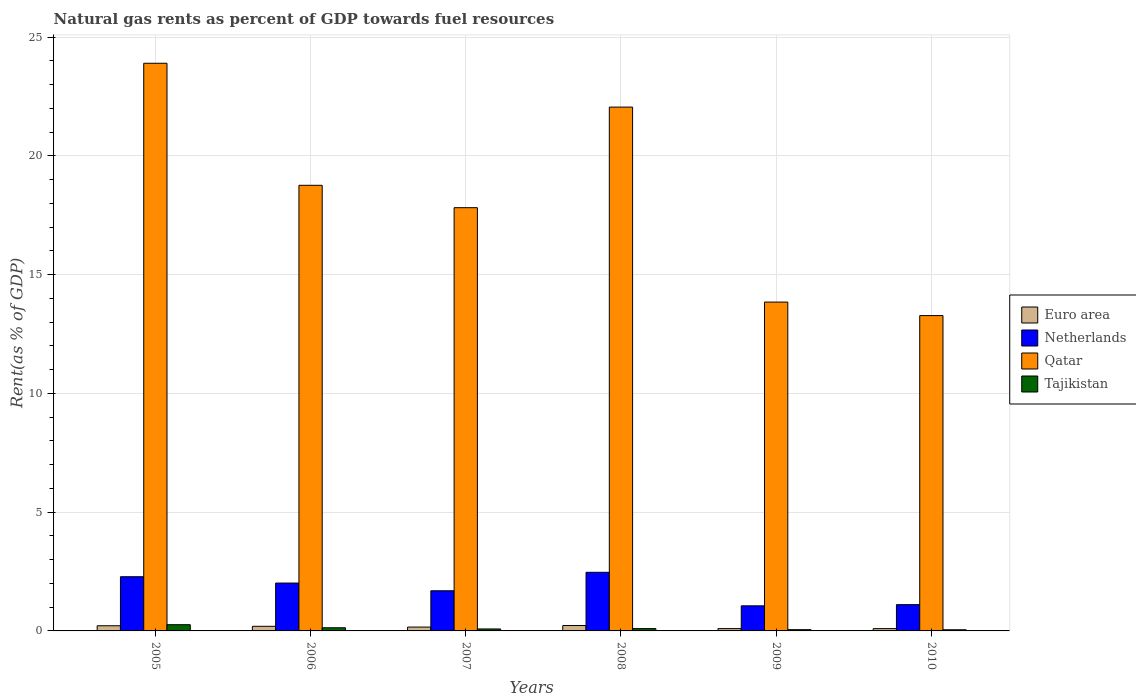How many different coloured bars are there?
Your answer should be very brief. 4. How many groups of bars are there?
Make the answer very short. 6. Are the number of bars on each tick of the X-axis equal?
Provide a short and direct response. Yes. How many bars are there on the 4th tick from the right?
Offer a terse response. 4. In how many cases, is the number of bars for a given year not equal to the number of legend labels?
Your answer should be very brief. 0. What is the matural gas rent in Tajikistan in 2006?
Keep it short and to the point. 0.13. Across all years, what is the maximum matural gas rent in Euro area?
Offer a terse response. 0.23. Across all years, what is the minimum matural gas rent in Netherlands?
Your answer should be compact. 1.06. In which year was the matural gas rent in Qatar minimum?
Provide a succinct answer. 2010. What is the total matural gas rent in Qatar in the graph?
Keep it short and to the point. 109.65. What is the difference between the matural gas rent in Netherlands in 2006 and that in 2009?
Your answer should be compact. 0.96. What is the difference between the matural gas rent in Euro area in 2005 and the matural gas rent in Qatar in 2009?
Provide a succinct answer. -13.63. What is the average matural gas rent in Qatar per year?
Your response must be concise. 18.27. In the year 2010, what is the difference between the matural gas rent in Netherlands and matural gas rent in Qatar?
Your response must be concise. -12.17. In how many years, is the matural gas rent in Tajikistan greater than 9 %?
Keep it short and to the point. 0. What is the ratio of the matural gas rent in Tajikistan in 2009 to that in 2010?
Your answer should be very brief. 1.09. What is the difference between the highest and the second highest matural gas rent in Euro area?
Offer a very short reply. 0.01. What is the difference between the highest and the lowest matural gas rent in Euro area?
Offer a terse response. 0.13. Is the sum of the matural gas rent in Qatar in 2007 and 2009 greater than the maximum matural gas rent in Tajikistan across all years?
Keep it short and to the point. Yes. Is it the case that in every year, the sum of the matural gas rent in Qatar and matural gas rent in Euro area is greater than the sum of matural gas rent in Netherlands and matural gas rent in Tajikistan?
Offer a terse response. No. What does the 1st bar from the right in 2006 represents?
Offer a terse response. Tajikistan. How many bars are there?
Provide a succinct answer. 24. Are all the bars in the graph horizontal?
Give a very brief answer. No. Are the values on the major ticks of Y-axis written in scientific E-notation?
Your answer should be very brief. No. How are the legend labels stacked?
Give a very brief answer. Vertical. What is the title of the graph?
Your response must be concise. Natural gas rents as percent of GDP towards fuel resources. Does "Kenya" appear as one of the legend labels in the graph?
Keep it short and to the point. No. What is the label or title of the Y-axis?
Your answer should be compact. Rent(as % of GDP). What is the Rent(as % of GDP) of Euro area in 2005?
Provide a succinct answer. 0.22. What is the Rent(as % of GDP) in Netherlands in 2005?
Ensure brevity in your answer.  2.28. What is the Rent(as % of GDP) in Qatar in 2005?
Ensure brevity in your answer.  23.9. What is the Rent(as % of GDP) of Tajikistan in 2005?
Offer a very short reply. 0.26. What is the Rent(as % of GDP) in Euro area in 2006?
Ensure brevity in your answer.  0.19. What is the Rent(as % of GDP) of Netherlands in 2006?
Your response must be concise. 2.02. What is the Rent(as % of GDP) in Qatar in 2006?
Keep it short and to the point. 18.76. What is the Rent(as % of GDP) of Tajikistan in 2006?
Provide a succinct answer. 0.13. What is the Rent(as % of GDP) in Euro area in 2007?
Provide a short and direct response. 0.16. What is the Rent(as % of GDP) in Netherlands in 2007?
Ensure brevity in your answer.  1.69. What is the Rent(as % of GDP) of Qatar in 2007?
Keep it short and to the point. 17.82. What is the Rent(as % of GDP) in Tajikistan in 2007?
Your answer should be compact. 0.08. What is the Rent(as % of GDP) in Euro area in 2008?
Offer a very short reply. 0.23. What is the Rent(as % of GDP) of Netherlands in 2008?
Provide a short and direct response. 2.47. What is the Rent(as % of GDP) of Qatar in 2008?
Keep it short and to the point. 22.05. What is the Rent(as % of GDP) in Tajikistan in 2008?
Provide a succinct answer. 0.1. What is the Rent(as % of GDP) in Euro area in 2009?
Ensure brevity in your answer.  0.1. What is the Rent(as % of GDP) in Netherlands in 2009?
Ensure brevity in your answer.  1.06. What is the Rent(as % of GDP) in Qatar in 2009?
Make the answer very short. 13.84. What is the Rent(as % of GDP) of Tajikistan in 2009?
Keep it short and to the point. 0.05. What is the Rent(as % of GDP) of Euro area in 2010?
Provide a succinct answer. 0.1. What is the Rent(as % of GDP) in Netherlands in 2010?
Provide a short and direct response. 1.11. What is the Rent(as % of GDP) of Qatar in 2010?
Your response must be concise. 13.28. What is the Rent(as % of GDP) of Tajikistan in 2010?
Give a very brief answer. 0.05. Across all years, what is the maximum Rent(as % of GDP) in Euro area?
Ensure brevity in your answer.  0.23. Across all years, what is the maximum Rent(as % of GDP) in Netherlands?
Your response must be concise. 2.47. Across all years, what is the maximum Rent(as % of GDP) in Qatar?
Make the answer very short. 23.9. Across all years, what is the maximum Rent(as % of GDP) in Tajikistan?
Make the answer very short. 0.26. Across all years, what is the minimum Rent(as % of GDP) in Euro area?
Keep it short and to the point. 0.1. Across all years, what is the minimum Rent(as % of GDP) of Netherlands?
Give a very brief answer. 1.06. Across all years, what is the minimum Rent(as % of GDP) of Qatar?
Offer a very short reply. 13.28. Across all years, what is the minimum Rent(as % of GDP) of Tajikistan?
Offer a very short reply. 0.05. What is the total Rent(as % of GDP) in Netherlands in the graph?
Keep it short and to the point. 10.62. What is the total Rent(as % of GDP) of Qatar in the graph?
Keep it short and to the point. 109.65. What is the total Rent(as % of GDP) in Tajikistan in the graph?
Your response must be concise. 0.68. What is the difference between the Rent(as % of GDP) of Euro area in 2005 and that in 2006?
Provide a succinct answer. 0.02. What is the difference between the Rent(as % of GDP) of Netherlands in 2005 and that in 2006?
Offer a very short reply. 0.27. What is the difference between the Rent(as % of GDP) in Qatar in 2005 and that in 2006?
Keep it short and to the point. 5.14. What is the difference between the Rent(as % of GDP) of Tajikistan in 2005 and that in 2006?
Keep it short and to the point. 0.13. What is the difference between the Rent(as % of GDP) in Euro area in 2005 and that in 2007?
Your answer should be compact. 0.06. What is the difference between the Rent(as % of GDP) in Netherlands in 2005 and that in 2007?
Ensure brevity in your answer.  0.59. What is the difference between the Rent(as % of GDP) in Qatar in 2005 and that in 2007?
Provide a succinct answer. 6.08. What is the difference between the Rent(as % of GDP) of Tajikistan in 2005 and that in 2007?
Provide a short and direct response. 0.18. What is the difference between the Rent(as % of GDP) in Euro area in 2005 and that in 2008?
Keep it short and to the point. -0.01. What is the difference between the Rent(as % of GDP) of Netherlands in 2005 and that in 2008?
Your answer should be compact. -0.19. What is the difference between the Rent(as % of GDP) of Qatar in 2005 and that in 2008?
Give a very brief answer. 1.85. What is the difference between the Rent(as % of GDP) of Tajikistan in 2005 and that in 2008?
Give a very brief answer. 0.16. What is the difference between the Rent(as % of GDP) of Euro area in 2005 and that in 2009?
Ensure brevity in your answer.  0.12. What is the difference between the Rent(as % of GDP) of Netherlands in 2005 and that in 2009?
Keep it short and to the point. 1.23. What is the difference between the Rent(as % of GDP) of Qatar in 2005 and that in 2009?
Make the answer very short. 10.05. What is the difference between the Rent(as % of GDP) in Tajikistan in 2005 and that in 2009?
Make the answer very short. 0.21. What is the difference between the Rent(as % of GDP) of Euro area in 2005 and that in 2010?
Your answer should be compact. 0.12. What is the difference between the Rent(as % of GDP) of Netherlands in 2005 and that in 2010?
Provide a succinct answer. 1.18. What is the difference between the Rent(as % of GDP) of Qatar in 2005 and that in 2010?
Your answer should be compact. 10.62. What is the difference between the Rent(as % of GDP) in Tajikistan in 2005 and that in 2010?
Make the answer very short. 0.21. What is the difference between the Rent(as % of GDP) of Euro area in 2006 and that in 2007?
Offer a terse response. 0.03. What is the difference between the Rent(as % of GDP) of Netherlands in 2006 and that in 2007?
Make the answer very short. 0.33. What is the difference between the Rent(as % of GDP) of Qatar in 2006 and that in 2007?
Your response must be concise. 0.94. What is the difference between the Rent(as % of GDP) of Tajikistan in 2006 and that in 2007?
Make the answer very short. 0.05. What is the difference between the Rent(as % of GDP) in Euro area in 2006 and that in 2008?
Provide a short and direct response. -0.03. What is the difference between the Rent(as % of GDP) in Netherlands in 2006 and that in 2008?
Your answer should be compact. -0.45. What is the difference between the Rent(as % of GDP) of Qatar in 2006 and that in 2008?
Ensure brevity in your answer.  -3.29. What is the difference between the Rent(as % of GDP) in Tajikistan in 2006 and that in 2008?
Your answer should be very brief. 0.04. What is the difference between the Rent(as % of GDP) in Euro area in 2006 and that in 2009?
Provide a succinct answer. 0.1. What is the difference between the Rent(as % of GDP) of Netherlands in 2006 and that in 2009?
Offer a terse response. 0.96. What is the difference between the Rent(as % of GDP) in Qatar in 2006 and that in 2009?
Your answer should be compact. 4.92. What is the difference between the Rent(as % of GDP) of Tajikistan in 2006 and that in 2009?
Offer a terse response. 0.08. What is the difference between the Rent(as % of GDP) of Euro area in 2006 and that in 2010?
Give a very brief answer. 0.1. What is the difference between the Rent(as % of GDP) in Netherlands in 2006 and that in 2010?
Your answer should be compact. 0.91. What is the difference between the Rent(as % of GDP) of Qatar in 2006 and that in 2010?
Your response must be concise. 5.48. What is the difference between the Rent(as % of GDP) of Tajikistan in 2006 and that in 2010?
Your response must be concise. 0.08. What is the difference between the Rent(as % of GDP) in Euro area in 2007 and that in 2008?
Make the answer very short. -0.07. What is the difference between the Rent(as % of GDP) of Netherlands in 2007 and that in 2008?
Make the answer very short. -0.78. What is the difference between the Rent(as % of GDP) of Qatar in 2007 and that in 2008?
Your response must be concise. -4.23. What is the difference between the Rent(as % of GDP) in Tajikistan in 2007 and that in 2008?
Give a very brief answer. -0.02. What is the difference between the Rent(as % of GDP) in Euro area in 2007 and that in 2009?
Your answer should be compact. 0.06. What is the difference between the Rent(as % of GDP) in Netherlands in 2007 and that in 2009?
Provide a succinct answer. 0.63. What is the difference between the Rent(as % of GDP) of Qatar in 2007 and that in 2009?
Your answer should be very brief. 3.97. What is the difference between the Rent(as % of GDP) in Tajikistan in 2007 and that in 2009?
Offer a very short reply. 0.03. What is the difference between the Rent(as % of GDP) of Euro area in 2007 and that in 2010?
Give a very brief answer. 0.07. What is the difference between the Rent(as % of GDP) of Netherlands in 2007 and that in 2010?
Keep it short and to the point. 0.58. What is the difference between the Rent(as % of GDP) of Qatar in 2007 and that in 2010?
Provide a succinct answer. 4.54. What is the difference between the Rent(as % of GDP) of Tajikistan in 2007 and that in 2010?
Provide a short and direct response. 0.03. What is the difference between the Rent(as % of GDP) in Euro area in 2008 and that in 2009?
Your response must be concise. 0.13. What is the difference between the Rent(as % of GDP) of Netherlands in 2008 and that in 2009?
Provide a short and direct response. 1.41. What is the difference between the Rent(as % of GDP) of Qatar in 2008 and that in 2009?
Keep it short and to the point. 8.21. What is the difference between the Rent(as % of GDP) of Tajikistan in 2008 and that in 2009?
Provide a short and direct response. 0.05. What is the difference between the Rent(as % of GDP) of Euro area in 2008 and that in 2010?
Give a very brief answer. 0.13. What is the difference between the Rent(as % of GDP) in Netherlands in 2008 and that in 2010?
Give a very brief answer. 1.36. What is the difference between the Rent(as % of GDP) of Qatar in 2008 and that in 2010?
Your answer should be very brief. 8.78. What is the difference between the Rent(as % of GDP) in Tajikistan in 2008 and that in 2010?
Your answer should be compact. 0.05. What is the difference between the Rent(as % of GDP) of Euro area in 2009 and that in 2010?
Offer a terse response. 0. What is the difference between the Rent(as % of GDP) of Netherlands in 2009 and that in 2010?
Make the answer very short. -0.05. What is the difference between the Rent(as % of GDP) of Qatar in 2009 and that in 2010?
Keep it short and to the point. 0.57. What is the difference between the Rent(as % of GDP) of Tajikistan in 2009 and that in 2010?
Give a very brief answer. 0. What is the difference between the Rent(as % of GDP) in Euro area in 2005 and the Rent(as % of GDP) in Netherlands in 2006?
Your answer should be compact. -1.8. What is the difference between the Rent(as % of GDP) of Euro area in 2005 and the Rent(as % of GDP) of Qatar in 2006?
Your response must be concise. -18.54. What is the difference between the Rent(as % of GDP) in Euro area in 2005 and the Rent(as % of GDP) in Tajikistan in 2006?
Your response must be concise. 0.08. What is the difference between the Rent(as % of GDP) in Netherlands in 2005 and the Rent(as % of GDP) in Qatar in 2006?
Your answer should be compact. -16.48. What is the difference between the Rent(as % of GDP) of Netherlands in 2005 and the Rent(as % of GDP) of Tajikistan in 2006?
Provide a short and direct response. 2.15. What is the difference between the Rent(as % of GDP) of Qatar in 2005 and the Rent(as % of GDP) of Tajikistan in 2006?
Make the answer very short. 23.76. What is the difference between the Rent(as % of GDP) in Euro area in 2005 and the Rent(as % of GDP) in Netherlands in 2007?
Provide a short and direct response. -1.47. What is the difference between the Rent(as % of GDP) in Euro area in 2005 and the Rent(as % of GDP) in Qatar in 2007?
Your answer should be compact. -17.6. What is the difference between the Rent(as % of GDP) in Euro area in 2005 and the Rent(as % of GDP) in Tajikistan in 2007?
Give a very brief answer. 0.14. What is the difference between the Rent(as % of GDP) in Netherlands in 2005 and the Rent(as % of GDP) in Qatar in 2007?
Provide a short and direct response. -15.54. What is the difference between the Rent(as % of GDP) in Netherlands in 2005 and the Rent(as % of GDP) in Tajikistan in 2007?
Provide a succinct answer. 2.2. What is the difference between the Rent(as % of GDP) of Qatar in 2005 and the Rent(as % of GDP) of Tajikistan in 2007?
Offer a terse response. 23.82. What is the difference between the Rent(as % of GDP) of Euro area in 2005 and the Rent(as % of GDP) of Netherlands in 2008?
Ensure brevity in your answer.  -2.25. What is the difference between the Rent(as % of GDP) of Euro area in 2005 and the Rent(as % of GDP) of Qatar in 2008?
Offer a very short reply. -21.83. What is the difference between the Rent(as % of GDP) of Euro area in 2005 and the Rent(as % of GDP) of Tajikistan in 2008?
Give a very brief answer. 0.12. What is the difference between the Rent(as % of GDP) of Netherlands in 2005 and the Rent(as % of GDP) of Qatar in 2008?
Your response must be concise. -19.77. What is the difference between the Rent(as % of GDP) of Netherlands in 2005 and the Rent(as % of GDP) of Tajikistan in 2008?
Your response must be concise. 2.18. What is the difference between the Rent(as % of GDP) of Qatar in 2005 and the Rent(as % of GDP) of Tajikistan in 2008?
Provide a short and direct response. 23.8. What is the difference between the Rent(as % of GDP) of Euro area in 2005 and the Rent(as % of GDP) of Netherlands in 2009?
Your answer should be very brief. -0.84. What is the difference between the Rent(as % of GDP) of Euro area in 2005 and the Rent(as % of GDP) of Qatar in 2009?
Ensure brevity in your answer.  -13.63. What is the difference between the Rent(as % of GDP) of Euro area in 2005 and the Rent(as % of GDP) of Tajikistan in 2009?
Your answer should be very brief. 0.16. What is the difference between the Rent(as % of GDP) in Netherlands in 2005 and the Rent(as % of GDP) in Qatar in 2009?
Your answer should be very brief. -11.56. What is the difference between the Rent(as % of GDP) in Netherlands in 2005 and the Rent(as % of GDP) in Tajikistan in 2009?
Your response must be concise. 2.23. What is the difference between the Rent(as % of GDP) in Qatar in 2005 and the Rent(as % of GDP) in Tajikistan in 2009?
Give a very brief answer. 23.85. What is the difference between the Rent(as % of GDP) of Euro area in 2005 and the Rent(as % of GDP) of Netherlands in 2010?
Make the answer very short. -0.89. What is the difference between the Rent(as % of GDP) in Euro area in 2005 and the Rent(as % of GDP) in Qatar in 2010?
Provide a short and direct response. -13.06. What is the difference between the Rent(as % of GDP) in Euro area in 2005 and the Rent(as % of GDP) in Tajikistan in 2010?
Your answer should be very brief. 0.17. What is the difference between the Rent(as % of GDP) of Netherlands in 2005 and the Rent(as % of GDP) of Qatar in 2010?
Your answer should be very brief. -10.99. What is the difference between the Rent(as % of GDP) in Netherlands in 2005 and the Rent(as % of GDP) in Tajikistan in 2010?
Provide a short and direct response. 2.23. What is the difference between the Rent(as % of GDP) in Qatar in 2005 and the Rent(as % of GDP) in Tajikistan in 2010?
Make the answer very short. 23.85. What is the difference between the Rent(as % of GDP) of Euro area in 2006 and the Rent(as % of GDP) of Netherlands in 2007?
Provide a short and direct response. -1.5. What is the difference between the Rent(as % of GDP) in Euro area in 2006 and the Rent(as % of GDP) in Qatar in 2007?
Keep it short and to the point. -17.62. What is the difference between the Rent(as % of GDP) in Euro area in 2006 and the Rent(as % of GDP) in Tajikistan in 2007?
Ensure brevity in your answer.  0.11. What is the difference between the Rent(as % of GDP) in Netherlands in 2006 and the Rent(as % of GDP) in Qatar in 2007?
Your response must be concise. -15.8. What is the difference between the Rent(as % of GDP) in Netherlands in 2006 and the Rent(as % of GDP) in Tajikistan in 2007?
Your answer should be very brief. 1.93. What is the difference between the Rent(as % of GDP) in Qatar in 2006 and the Rent(as % of GDP) in Tajikistan in 2007?
Offer a very short reply. 18.68. What is the difference between the Rent(as % of GDP) of Euro area in 2006 and the Rent(as % of GDP) of Netherlands in 2008?
Your answer should be compact. -2.27. What is the difference between the Rent(as % of GDP) of Euro area in 2006 and the Rent(as % of GDP) of Qatar in 2008?
Your answer should be compact. -21.86. What is the difference between the Rent(as % of GDP) in Euro area in 2006 and the Rent(as % of GDP) in Tajikistan in 2008?
Keep it short and to the point. 0.1. What is the difference between the Rent(as % of GDP) in Netherlands in 2006 and the Rent(as % of GDP) in Qatar in 2008?
Your response must be concise. -20.04. What is the difference between the Rent(as % of GDP) of Netherlands in 2006 and the Rent(as % of GDP) of Tajikistan in 2008?
Your response must be concise. 1.92. What is the difference between the Rent(as % of GDP) of Qatar in 2006 and the Rent(as % of GDP) of Tajikistan in 2008?
Your answer should be very brief. 18.66. What is the difference between the Rent(as % of GDP) of Euro area in 2006 and the Rent(as % of GDP) of Netherlands in 2009?
Offer a very short reply. -0.86. What is the difference between the Rent(as % of GDP) of Euro area in 2006 and the Rent(as % of GDP) of Qatar in 2009?
Your answer should be very brief. -13.65. What is the difference between the Rent(as % of GDP) of Euro area in 2006 and the Rent(as % of GDP) of Tajikistan in 2009?
Your answer should be very brief. 0.14. What is the difference between the Rent(as % of GDP) in Netherlands in 2006 and the Rent(as % of GDP) in Qatar in 2009?
Your response must be concise. -11.83. What is the difference between the Rent(as % of GDP) of Netherlands in 2006 and the Rent(as % of GDP) of Tajikistan in 2009?
Your response must be concise. 1.96. What is the difference between the Rent(as % of GDP) in Qatar in 2006 and the Rent(as % of GDP) in Tajikistan in 2009?
Offer a very short reply. 18.71. What is the difference between the Rent(as % of GDP) of Euro area in 2006 and the Rent(as % of GDP) of Netherlands in 2010?
Give a very brief answer. -0.91. What is the difference between the Rent(as % of GDP) in Euro area in 2006 and the Rent(as % of GDP) in Qatar in 2010?
Your response must be concise. -13.08. What is the difference between the Rent(as % of GDP) of Euro area in 2006 and the Rent(as % of GDP) of Tajikistan in 2010?
Offer a terse response. 0.15. What is the difference between the Rent(as % of GDP) in Netherlands in 2006 and the Rent(as % of GDP) in Qatar in 2010?
Your answer should be very brief. -11.26. What is the difference between the Rent(as % of GDP) in Netherlands in 2006 and the Rent(as % of GDP) in Tajikistan in 2010?
Your answer should be compact. 1.97. What is the difference between the Rent(as % of GDP) of Qatar in 2006 and the Rent(as % of GDP) of Tajikistan in 2010?
Your response must be concise. 18.71. What is the difference between the Rent(as % of GDP) in Euro area in 2007 and the Rent(as % of GDP) in Netherlands in 2008?
Offer a very short reply. -2.31. What is the difference between the Rent(as % of GDP) in Euro area in 2007 and the Rent(as % of GDP) in Qatar in 2008?
Provide a short and direct response. -21.89. What is the difference between the Rent(as % of GDP) of Euro area in 2007 and the Rent(as % of GDP) of Tajikistan in 2008?
Give a very brief answer. 0.06. What is the difference between the Rent(as % of GDP) in Netherlands in 2007 and the Rent(as % of GDP) in Qatar in 2008?
Give a very brief answer. -20.36. What is the difference between the Rent(as % of GDP) in Netherlands in 2007 and the Rent(as % of GDP) in Tajikistan in 2008?
Your answer should be very brief. 1.59. What is the difference between the Rent(as % of GDP) in Qatar in 2007 and the Rent(as % of GDP) in Tajikistan in 2008?
Keep it short and to the point. 17.72. What is the difference between the Rent(as % of GDP) of Euro area in 2007 and the Rent(as % of GDP) of Netherlands in 2009?
Provide a succinct answer. -0.89. What is the difference between the Rent(as % of GDP) of Euro area in 2007 and the Rent(as % of GDP) of Qatar in 2009?
Your answer should be very brief. -13.68. What is the difference between the Rent(as % of GDP) in Euro area in 2007 and the Rent(as % of GDP) in Tajikistan in 2009?
Offer a terse response. 0.11. What is the difference between the Rent(as % of GDP) in Netherlands in 2007 and the Rent(as % of GDP) in Qatar in 2009?
Make the answer very short. -12.15. What is the difference between the Rent(as % of GDP) of Netherlands in 2007 and the Rent(as % of GDP) of Tajikistan in 2009?
Provide a short and direct response. 1.64. What is the difference between the Rent(as % of GDP) in Qatar in 2007 and the Rent(as % of GDP) in Tajikistan in 2009?
Provide a short and direct response. 17.77. What is the difference between the Rent(as % of GDP) of Euro area in 2007 and the Rent(as % of GDP) of Netherlands in 2010?
Give a very brief answer. -0.94. What is the difference between the Rent(as % of GDP) of Euro area in 2007 and the Rent(as % of GDP) of Qatar in 2010?
Provide a succinct answer. -13.11. What is the difference between the Rent(as % of GDP) of Euro area in 2007 and the Rent(as % of GDP) of Tajikistan in 2010?
Provide a succinct answer. 0.11. What is the difference between the Rent(as % of GDP) in Netherlands in 2007 and the Rent(as % of GDP) in Qatar in 2010?
Give a very brief answer. -11.59. What is the difference between the Rent(as % of GDP) of Netherlands in 2007 and the Rent(as % of GDP) of Tajikistan in 2010?
Give a very brief answer. 1.64. What is the difference between the Rent(as % of GDP) in Qatar in 2007 and the Rent(as % of GDP) in Tajikistan in 2010?
Your response must be concise. 17.77. What is the difference between the Rent(as % of GDP) of Euro area in 2008 and the Rent(as % of GDP) of Netherlands in 2009?
Offer a terse response. -0.83. What is the difference between the Rent(as % of GDP) in Euro area in 2008 and the Rent(as % of GDP) in Qatar in 2009?
Your answer should be very brief. -13.62. What is the difference between the Rent(as % of GDP) of Euro area in 2008 and the Rent(as % of GDP) of Tajikistan in 2009?
Give a very brief answer. 0.17. What is the difference between the Rent(as % of GDP) in Netherlands in 2008 and the Rent(as % of GDP) in Qatar in 2009?
Keep it short and to the point. -11.38. What is the difference between the Rent(as % of GDP) in Netherlands in 2008 and the Rent(as % of GDP) in Tajikistan in 2009?
Your response must be concise. 2.42. What is the difference between the Rent(as % of GDP) in Qatar in 2008 and the Rent(as % of GDP) in Tajikistan in 2009?
Offer a very short reply. 22. What is the difference between the Rent(as % of GDP) of Euro area in 2008 and the Rent(as % of GDP) of Netherlands in 2010?
Give a very brief answer. -0.88. What is the difference between the Rent(as % of GDP) of Euro area in 2008 and the Rent(as % of GDP) of Qatar in 2010?
Offer a very short reply. -13.05. What is the difference between the Rent(as % of GDP) in Euro area in 2008 and the Rent(as % of GDP) in Tajikistan in 2010?
Your response must be concise. 0.18. What is the difference between the Rent(as % of GDP) of Netherlands in 2008 and the Rent(as % of GDP) of Qatar in 2010?
Ensure brevity in your answer.  -10.81. What is the difference between the Rent(as % of GDP) of Netherlands in 2008 and the Rent(as % of GDP) of Tajikistan in 2010?
Provide a succinct answer. 2.42. What is the difference between the Rent(as % of GDP) of Qatar in 2008 and the Rent(as % of GDP) of Tajikistan in 2010?
Give a very brief answer. 22. What is the difference between the Rent(as % of GDP) in Euro area in 2009 and the Rent(as % of GDP) in Netherlands in 2010?
Keep it short and to the point. -1.01. What is the difference between the Rent(as % of GDP) in Euro area in 2009 and the Rent(as % of GDP) in Qatar in 2010?
Make the answer very short. -13.18. What is the difference between the Rent(as % of GDP) in Euro area in 2009 and the Rent(as % of GDP) in Tajikistan in 2010?
Offer a terse response. 0.05. What is the difference between the Rent(as % of GDP) in Netherlands in 2009 and the Rent(as % of GDP) in Qatar in 2010?
Your answer should be very brief. -12.22. What is the difference between the Rent(as % of GDP) in Netherlands in 2009 and the Rent(as % of GDP) in Tajikistan in 2010?
Your answer should be compact. 1.01. What is the difference between the Rent(as % of GDP) in Qatar in 2009 and the Rent(as % of GDP) in Tajikistan in 2010?
Your answer should be compact. 13.8. What is the average Rent(as % of GDP) of Euro area per year?
Your answer should be compact. 0.17. What is the average Rent(as % of GDP) in Netherlands per year?
Your response must be concise. 1.77. What is the average Rent(as % of GDP) in Qatar per year?
Offer a terse response. 18.27. What is the average Rent(as % of GDP) in Tajikistan per year?
Offer a terse response. 0.11. In the year 2005, what is the difference between the Rent(as % of GDP) in Euro area and Rent(as % of GDP) in Netherlands?
Ensure brevity in your answer.  -2.06. In the year 2005, what is the difference between the Rent(as % of GDP) in Euro area and Rent(as % of GDP) in Qatar?
Provide a short and direct response. -23.68. In the year 2005, what is the difference between the Rent(as % of GDP) in Euro area and Rent(as % of GDP) in Tajikistan?
Your answer should be compact. -0.04. In the year 2005, what is the difference between the Rent(as % of GDP) in Netherlands and Rent(as % of GDP) in Qatar?
Offer a terse response. -21.62. In the year 2005, what is the difference between the Rent(as % of GDP) in Netherlands and Rent(as % of GDP) in Tajikistan?
Offer a terse response. 2.02. In the year 2005, what is the difference between the Rent(as % of GDP) of Qatar and Rent(as % of GDP) of Tajikistan?
Offer a terse response. 23.64. In the year 2006, what is the difference between the Rent(as % of GDP) in Euro area and Rent(as % of GDP) in Netherlands?
Offer a very short reply. -1.82. In the year 2006, what is the difference between the Rent(as % of GDP) of Euro area and Rent(as % of GDP) of Qatar?
Offer a terse response. -18.57. In the year 2006, what is the difference between the Rent(as % of GDP) of Euro area and Rent(as % of GDP) of Tajikistan?
Keep it short and to the point. 0.06. In the year 2006, what is the difference between the Rent(as % of GDP) of Netherlands and Rent(as % of GDP) of Qatar?
Your answer should be compact. -16.74. In the year 2006, what is the difference between the Rent(as % of GDP) of Netherlands and Rent(as % of GDP) of Tajikistan?
Give a very brief answer. 1.88. In the year 2006, what is the difference between the Rent(as % of GDP) in Qatar and Rent(as % of GDP) in Tajikistan?
Offer a terse response. 18.63. In the year 2007, what is the difference between the Rent(as % of GDP) in Euro area and Rent(as % of GDP) in Netherlands?
Keep it short and to the point. -1.53. In the year 2007, what is the difference between the Rent(as % of GDP) in Euro area and Rent(as % of GDP) in Qatar?
Give a very brief answer. -17.66. In the year 2007, what is the difference between the Rent(as % of GDP) of Euro area and Rent(as % of GDP) of Tajikistan?
Keep it short and to the point. 0.08. In the year 2007, what is the difference between the Rent(as % of GDP) of Netherlands and Rent(as % of GDP) of Qatar?
Your answer should be very brief. -16.13. In the year 2007, what is the difference between the Rent(as % of GDP) of Netherlands and Rent(as % of GDP) of Tajikistan?
Make the answer very short. 1.61. In the year 2007, what is the difference between the Rent(as % of GDP) of Qatar and Rent(as % of GDP) of Tajikistan?
Your answer should be compact. 17.74. In the year 2008, what is the difference between the Rent(as % of GDP) in Euro area and Rent(as % of GDP) in Netherlands?
Your response must be concise. -2.24. In the year 2008, what is the difference between the Rent(as % of GDP) in Euro area and Rent(as % of GDP) in Qatar?
Offer a terse response. -21.83. In the year 2008, what is the difference between the Rent(as % of GDP) in Euro area and Rent(as % of GDP) in Tajikistan?
Offer a very short reply. 0.13. In the year 2008, what is the difference between the Rent(as % of GDP) in Netherlands and Rent(as % of GDP) in Qatar?
Provide a succinct answer. -19.58. In the year 2008, what is the difference between the Rent(as % of GDP) in Netherlands and Rent(as % of GDP) in Tajikistan?
Keep it short and to the point. 2.37. In the year 2008, what is the difference between the Rent(as % of GDP) of Qatar and Rent(as % of GDP) of Tajikistan?
Offer a very short reply. 21.95. In the year 2009, what is the difference between the Rent(as % of GDP) in Euro area and Rent(as % of GDP) in Netherlands?
Your answer should be very brief. -0.96. In the year 2009, what is the difference between the Rent(as % of GDP) of Euro area and Rent(as % of GDP) of Qatar?
Ensure brevity in your answer.  -13.75. In the year 2009, what is the difference between the Rent(as % of GDP) in Euro area and Rent(as % of GDP) in Tajikistan?
Provide a succinct answer. 0.05. In the year 2009, what is the difference between the Rent(as % of GDP) in Netherlands and Rent(as % of GDP) in Qatar?
Your response must be concise. -12.79. In the year 2009, what is the difference between the Rent(as % of GDP) in Qatar and Rent(as % of GDP) in Tajikistan?
Your answer should be very brief. 13.79. In the year 2010, what is the difference between the Rent(as % of GDP) in Euro area and Rent(as % of GDP) in Netherlands?
Provide a succinct answer. -1.01. In the year 2010, what is the difference between the Rent(as % of GDP) in Euro area and Rent(as % of GDP) in Qatar?
Provide a short and direct response. -13.18. In the year 2010, what is the difference between the Rent(as % of GDP) in Euro area and Rent(as % of GDP) in Tajikistan?
Your response must be concise. 0.05. In the year 2010, what is the difference between the Rent(as % of GDP) in Netherlands and Rent(as % of GDP) in Qatar?
Keep it short and to the point. -12.17. In the year 2010, what is the difference between the Rent(as % of GDP) in Netherlands and Rent(as % of GDP) in Tajikistan?
Your response must be concise. 1.06. In the year 2010, what is the difference between the Rent(as % of GDP) in Qatar and Rent(as % of GDP) in Tajikistan?
Ensure brevity in your answer.  13.23. What is the ratio of the Rent(as % of GDP) of Euro area in 2005 to that in 2006?
Give a very brief answer. 1.12. What is the ratio of the Rent(as % of GDP) in Netherlands in 2005 to that in 2006?
Provide a short and direct response. 1.13. What is the ratio of the Rent(as % of GDP) of Qatar in 2005 to that in 2006?
Offer a very short reply. 1.27. What is the ratio of the Rent(as % of GDP) in Tajikistan in 2005 to that in 2006?
Offer a very short reply. 1.97. What is the ratio of the Rent(as % of GDP) of Euro area in 2005 to that in 2007?
Provide a short and direct response. 1.34. What is the ratio of the Rent(as % of GDP) in Netherlands in 2005 to that in 2007?
Provide a short and direct response. 1.35. What is the ratio of the Rent(as % of GDP) in Qatar in 2005 to that in 2007?
Make the answer very short. 1.34. What is the ratio of the Rent(as % of GDP) in Tajikistan in 2005 to that in 2007?
Keep it short and to the point. 3.18. What is the ratio of the Rent(as % of GDP) in Euro area in 2005 to that in 2008?
Your answer should be very brief. 0.96. What is the ratio of the Rent(as % of GDP) in Netherlands in 2005 to that in 2008?
Ensure brevity in your answer.  0.92. What is the ratio of the Rent(as % of GDP) in Qatar in 2005 to that in 2008?
Keep it short and to the point. 1.08. What is the ratio of the Rent(as % of GDP) of Tajikistan in 2005 to that in 2008?
Give a very brief answer. 2.68. What is the ratio of the Rent(as % of GDP) in Euro area in 2005 to that in 2009?
Provide a succinct answer. 2.22. What is the ratio of the Rent(as % of GDP) of Netherlands in 2005 to that in 2009?
Your answer should be compact. 2.16. What is the ratio of the Rent(as % of GDP) of Qatar in 2005 to that in 2009?
Provide a succinct answer. 1.73. What is the ratio of the Rent(as % of GDP) in Tajikistan in 2005 to that in 2009?
Give a very brief answer. 5. What is the ratio of the Rent(as % of GDP) of Euro area in 2005 to that in 2010?
Provide a succinct answer. 2.24. What is the ratio of the Rent(as % of GDP) of Netherlands in 2005 to that in 2010?
Offer a terse response. 2.06. What is the ratio of the Rent(as % of GDP) in Qatar in 2005 to that in 2010?
Offer a terse response. 1.8. What is the ratio of the Rent(as % of GDP) in Tajikistan in 2005 to that in 2010?
Make the answer very short. 5.45. What is the ratio of the Rent(as % of GDP) of Euro area in 2006 to that in 2007?
Provide a succinct answer. 1.2. What is the ratio of the Rent(as % of GDP) in Netherlands in 2006 to that in 2007?
Your response must be concise. 1.19. What is the ratio of the Rent(as % of GDP) of Qatar in 2006 to that in 2007?
Ensure brevity in your answer.  1.05. What is the ratio of the Rent(as % of GDP) in Tajikistan in 2006 to that in 2007?
Offer a terse response. 1.61. What is the ratio of the Rent(as % of GDP) in Euro area in 2006 to that in 2008?
Your response must be concise. 0.86. What is the ratio of the Rent(as % of GDP) of Netherlands in 2006 to that in 2008?
Provide a short and direct response. 0.82. What is the ratio of the Rent(as % of GDP) in Qatar in 2006 to that in 2008?
Your response must be concise. 0.85. What is the ratio of the Rent(as % of GDP) in Tajikistan in 2006 to that in 2008?
Provide a short and direct response. 1.36. What is the ratio of the Rent(as % of GDP) of Euro area in 2006 to that in 2009?
Keep it short and to the point. 1.99. What is the ratio of the Rent(as % of GDP) in Netherlands in 2006 to that in 2009?
Offer a very short reply. 1.91. What is the ratio of the Rent(as % of GDP) of Qatar in 2006 to that in 2009?
Offer a terse response. 1.36. What is the ratio of the Rent(as % of GDP) in Tajikistan in 2006 to that in 2009?
Keep it short and to the point. 2.54. What is the ratio of the Rent(as % of GDP) of Euro area in 2006 to that in 2010?
Keep it short and to the point. 2.01. What is the ratio of the Rent(as % of GDP) in Netherlands in 2006 to that in 2010?
Ensure brevity in your answer.  1.82. What is the ratio of the Rent(as % of GDP) of Qatar in 2006 to that in 2010?
Your answer should be compact. 1.41. What is the ratio of the Rent(as % of GDP) of Tajikistan in 2006 to that in 2010?
Keep it short and to the point. 2.76. What is the ratio of the Rent(as % of GDP) of Euro area in 2007 to that in 2008?
Offer a very short reply. 0.71. What is the ratio of the Rent(as % of GDP) in Netherlands in 2007 to that in 2008?
Your response must be concise. 0.68. What is the ratio of the Rent(as % of GDP) of Qatar in 2007 to that in 2008?
Offer a terse response. 0.81. What is the ratio of the Rent(as % of GDP) of Tajikistan in 2007 to that in 2008?
Your answer should be compact. 0.84. What is the ratio of the Rent(as % of GDP) of Euro area in 2007 to that in 2009?
Make the answer very short. 1.66. What is the ratio of the Rent(as % of GDP) of Qatar in 2007 to that in 2009?
Keep it short and to the point. 1.29. What is the ratio of the Rent(as % of GDP) in Tajikistan in 2007 to that in 2009?
Ensure brevity in your answer.  1.57. What is the ratio of the Rent(as % of GDP) in Euro area in 2007 to that in 2010?
Make the answer very short. 1.67. What is the ratio of the Rent(as % of GDP) of Netherlands in 2007 to that in 2010?
Make the answer very short. 1.53. What is the ratio of the Rent(as % of GDP) in Qatar in 2007 to that in 2010?
Keep it short and to the point. 1.34. What is the ratio of the Rent(as % of GDP) of Tajikistan in 2007 to that in 2010?
Make the answer very short. 1.71. What is the ratio of the Rent(as % of GDP) of Euro area in 2008 to that in 2009?
Offer a terse response. 2.32. What is the ratio of the Rent(as % of GDP) of Netherlands in 2008 to that in 2009?
Make the answer very short. 2.34. What is the ratio of the Rent(as % of GDP) of Qatar in 2008 to that in 2009?
Provide a succinct answer. 1.59. What is the ratio of the Rent(as % of GDP) in Tajikistan in 2008 to that in 2009?
Offer a terse response. 1.86. What is the ratio of the Rent(as % of GDP) in Euro area in 2008 to that in 2010?
Make the answer very short. 2.34. What is the ratio of the Rent(as % of GDP) of Netherlands in 2008 to that in 2010?
Provide a succinct answer. 2.23. What is the ratio of the Rent(as % of GDP) of Qatar in 2008 to that in 2010?
Provide a succinct answer. 1.66. What is the ratio of the Rent(as % of GDP) in Tajikistan in 2008 to that in 2010?
Make the answer very short. 2.03. What is the ratio of the Rent(as % of GDP) in Netherlands in 2009 to that in 2010?
Give a very brief answer. 0.96. What is the ratio of the Rent(as % of GDP) in Qatar in 2009 to that in 2010?
Give a very brief answer. 1.04. What is the ratio of the Rent(as % of GDP) in Tajikistan in 2009 to that in 2010?
Your answer should be very brief. 1.09. What is the difference between the highest and the second highest Rent(as % of GDP) of Euro area?
Offer a very short reply. 0.01. What is the difference between the highest and the second highest Rent(as % of GDP) of Netherlands?
Offer a very short reply. 0.19. What is the difference between the highest and the second highest Rent(as % of GDP) of Qatar?
Offer a terse response. 1.85. What is the difference between the highest and the second highest Rent(as % of GDP) of Tajikistan?
Your answer should be very brief. 0.13. What is the difference between the highest and the lowest Rent(as % of GDP) of Euro area?
Provide a succinct answer. 0.13. What is the difference between the highest and the lowest Rent(as % of GDP) in Netherlands?
Your answer should be compact. 1.41. What is the difference between the highest and the lowest Rent(as % of GDP) in Qatar?
Provide a short and direct response. 10.62. What is the difference between the highest and the lowest Rent(as % of GDP) of Tajikistan?
Your answer should be compact. 0.21. 